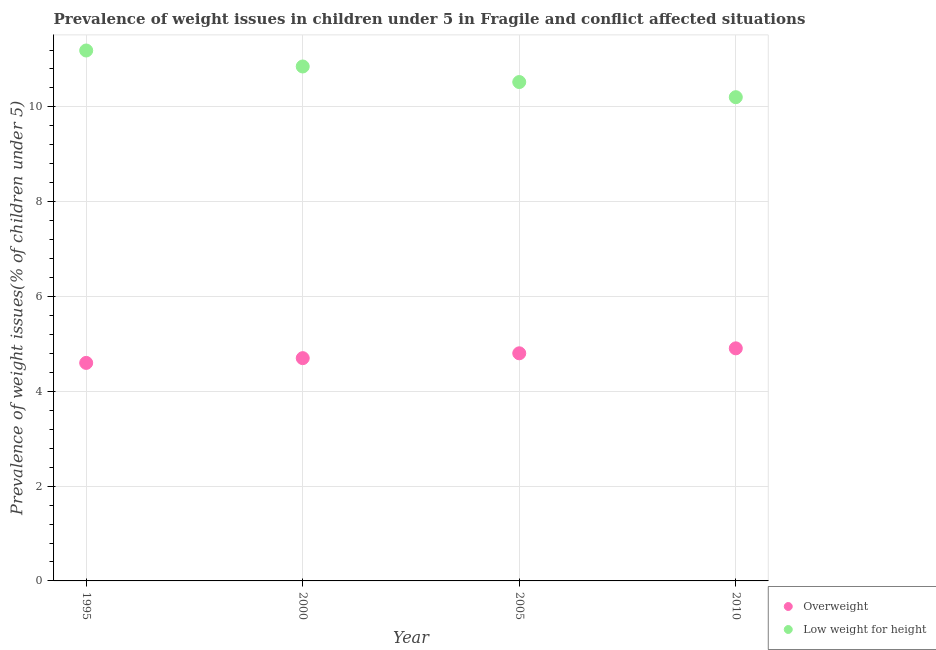How many different coloured dotlines are there?
Your response must be concise. 2. What is the percentage of underweight children in 2010?
Offer a very short reply. 10.2. Across all years, what is the maximum percentage of overweight children?
Ensure brevity in your answer.  4.91. Across all years, what is the minimum percentage of underweight children?
Provide a short and direct response. 10.2. In which year was the percentage of underweight children maximum?
Your response must be concise. 1995. In which year was the percentage of overweight children minimum?
Your response must be concise. 1995. What is the total percentage of underweight children in the graph?
Your answer should be compact. 42.77. What is the difference between the percentage of overweight children in 1995 and that in 2005?
Ensure brevity in your answer.  -0.2. What is the difference between the percentage of underweight children in 2010 and the percentage of overweight children in 1995?
Your response must be concise. 5.61. What is the average percentage of overweight children per year?
Give a very brief answer. 4.75. In the year 2005, what is the difference between the percentage of underweight children and percentage of overweight children?
Make the answer very short. 5.72. What is the ratio of the percentage of underweight children in 1995 to that in 2010?
Give a very brief answer. 1.1. What is the difference between the highest and the second highest percentage of underweight children?
Make the answer very short. 0.34. What is the difference between the highest and the lowest percentage of underweight children?
Provide a short and direct response. 0.99. In how many years, is the percentage of underweight children greater than the average percentage of underweight children taken over all years?
Ensure brevity in your answer.  2. Is the sum of the percentage of overweight children in 2000 and 2005 greater than the maximum percentage of underweight children across all years?
Make the answer very short. No. Is the percentage of overweight children strictly less than the percentage of underweight children over the years?
Make the answer very short. Yes. How many dotlines are there?
Your answer should be very brief. 2. How many years are there in the graph?
Your answer should be very brief. 4. Are the values on the major ticks of Y-axis written in scientific E-notation?
Offer a very short reply. No. Where does the legend appear in the graph?
Your response must be concise. Bottom right. How are the legend labels stacked?
Your response must be concise. Vertical. What is the title of the graph?
Give a very brief answer. Prevalence of weight issues in children under 5 in Fragile and conflict affected situations. Does "From production" appear as one of the legend labels in the graph?
Ensure brevity in your answer.  No. What is the label or title of the Y-axis?
Make the answer very short. Prevalence of weight issues(% of children under 5). What is the Prevalence of weight issues(% of children under 5) in Overweight in 1995?
Provide a short and direct response. 4.6. What is the Prevalence of weight issues(% of children under 5) in Low weight for height in 1995?
Give a very brief answer. 11.19. What is the Prevalence of weight issues(% of children under 5) of Overweight in 2000?
Keep it short and to the point. 4.7. What is the Prevalence of weight issues(% of children under 5) in Low weight for height in 2000?
Offer a terse response. 10.85. What is the Prevalence of weight issues(% of children under 5) of Overweight in 2005?
Ensure brevity in your answer.  4.8. What is the Prevalence of weight issues(% of children under 5) of Low weight for height in 2005?
Your answer should be compact. 10.52. What is the Prevalence of weight issues(% of children under 5) of Overweight in 2010?
Make the answer very short. 4.91. What is the Prevalence of weight issues(% of children under 5) in Low weight for height in 2010?
Provide a short and direct response. 10.2. Across all years, what is the maximum Prevalence of weight issues(% of children under 5) in Overweight?
Your answer should be very brief. 4.91. Across all years, what is the maximum Prevalence of weight issues(% of children under 5) of Low weight for height?
Keep it short and to the point. 11.19. Across all years, what is the minimum Prevalence of weight issues(% of children under 5) in Overweight?
Ensure brevity in your answer.  4.6. Across all years, what is the minimum Prevalence of weight issues(% of children under 5) of Low weight for height?
Provide a succinct answer. 10.2. What is the total Prevalence of weight issues(% of children under 5) in Overweight in the graph?
Keep it short and to the point. 19.01. What is the total Prevalence of weight issues(% of children under 5) of Low weight for height in the graph?
Your answer should be compact. 42.77. What is the difference between the Prevalence of weight issues(% of children under 5) in Overweight in 1995 and that in 2000?
Offer a terse response. -0.1. What is the difference between the Prevalence of weight issues(% of children under 5) in Low weight for height in 1995 and that in 2000?
Provide a short and direct response. 0.34. What is the difference between the Prevalence of weight issues(% of children under 5) in Overweight in 1995 and that in 2005?
Give a very brief answer. -0.2. What is the difference between the Prevalence of weight issues(% of children under 5) in Low weight for height in 1995 and that in 2005?
Your response must be concise. 0.67. What is the difference between the Prevalence of weight issues(% of children under 5) of Overweight in 1995 and that in 2010?
Keep it short and to the point. -0.31. What is the difference between the Prevalence of weight issues(% of children under 5) of Low weight for height in 1995 and that in 2010?
Offer a very short reply. 0.99. What is the difference between the Prevalence of weight issues(% of children under 5) of Overweight in 2000 and that in 2005?
Make the answer very short. -0.1. What is the difference between the Prevalence of weight issues(% of children under 5) of Low weight for height in 2000 and that in 2005?
Make the answer very short. 0.33. What is the difference between the Prevalence of weight issues(% of children under 5) in Overweight in 2000 and that in 2010?
Your answer should be very brief. -0.21. What is the difference between the Prevalence of weight issues(% of children under 5) in Low weight for height in 2000 and that in 2010?
Keep it short and to the point. 0.65. What is the difference between the Prevalence of weight issues(% of children under 5) of Overweight in 2005 and that in 2010?
Your response must be concise. -0.1. What is the difference between the Prevalence of weight issues(% of children under 5) of Low weight for height in 2005 and that in 2010?
Give a very brief answer. 0.32. What is the difference between the Prevalence of weight issues(% of children under 5) of Overweight in 1995 and the Prevalence of weight issues(% of children under 5) of Low weight for height in 2000?
Keep it short and to the point. -6.25. What is the difference between the Prevalence of weight issues(% of children under 5) in Overweight in 1995 and the Prevalence of weight issues(% of children under 5) in Low weight for height in 2005?
Your response must be concise. -5.93. What is the difference between the Prevalence of weight issues(% of children under 5) in Overweight in 1995 and the Prevalence of weight issues(% of children under 5) in Low weight for height in 2010?
Keep it short and to the point. -5.61. What is the difference between the Prevalence of weight issues(% of children under 5) of Overweight in 2000 and the Prevalence of weight issues(% of children under 5) of Low weight for height in 2005?
Provide a short and direct response. -5.82. What is the difference between the Prevalence of weight issues(% of children under 5) of Overweight in 2000 and the Prevalence of weight issues(% of children under 5) of Low weight for height in 2010?
Your answer should be very brief. -5.51. What is the difference between the Prevalence of weight issues(% of children under 5) in Overweight in 2005 and the Prevalence of weight issues(% of children under 5) in Low weight for height in 2010?
Give a very brief answer. -5.4. What is the average Prevalence of weight issues(% of children under 5) in Overweight per year?
Give a very brief answer. 4.75. What is the average Prevalence of weight issues(% of children under 5) in Low weight for height per year?
Provide a succinct answer. 10.69. In the year 1995, what is the difference between the Prevalence of weight issues(% of children under 5) in Overweight and Prevalence of weight issues(% of children under 5) in Low weight for height?
Provide a succinct answer. -6.59. In the year 2000, what is the difference between the Prevalence of weight issues(% of children under 5) of Overweight and Prevalence of weight issues(% of children under 5) of Low weight for height?
Provide a succinct answer. -6.15. In the year 2005, what is the difference between the Prevalence of weight issues(% of children under 5) of Overweight and Prevalence of weight issues(% of children under 5) of Low weight for height?
Your response must be concise. -5.72. In the year 2010, what is the difference between the Prevalence of weight issues(% of children under 5) of Overweight and Prevalence of weight issues(% of children under 5) of Low weight for height?
Give a very brief answer. -5.3. What is the ratio of the Prevalence of weight issues(% of children under 5) of Overweight in 1995 to that in 2000?
Ensure brevity in your answer.  0.98. What is the ratio of the Prevalence of weight issues(% of children under 5) of Low weight for height in 1995 to that in 2000?
Make the answer very short. 1.03. What is the ratio of the Prevalence of weight issues(% of children under 5) of Overweight in 1995 to that in 2005?
Make the answer very short. 0.96. What is the ratio of the Prevalence of weight issues(% of children under 5) in Low weight for height in 1995 to that in 2005?
Your answer should be very brief. 1.06. What is the ratio of the Prevalence of weight issues(% of children under 5) of Overweight in 1995 to that in 2010?
Make the answer very short. 0.94. What is the ratio of the Prevalence of weight issues(% of children under 5) of Low weight for height in 1995 to that in 2010?
Provide a short and direct response. 1.1. What is the ratio of the Prevalence of weight issues(% of children under 5) of Overweight in 2000 to that in 2005?
Give a very brief answer. 0.98. What is the ratio of the Prevalence of weight issues(% of children under 5) in Low weight for height in 2000 to that in 2005?
Keep it short and to the point. 1.03. What is the ratio of the Prevalence of weight issues(% of children under 5) of Overweight in 2000 to that in 2010?
Offer a terse response. 0.96. What is the ratio of the Prevalence of weight issues(% of children under 5) in Low weight for height in 2000 to that in 2010?
Your answer should be compact. 1.06. What is the ratio of the Prevalence of weight issues(% of children under 5) in Overweight in 2005 to that in 2010?
Provide a short and direct response. 0.98. What is the ratio of the Prevalence of weight issues(% of children under 5) of Low weight for height in 2005 to that in 2010?
Your response must be concise. 1.03. What is the difference between the highest and the second highest Prevalence of weight issues(% of children under 5) of Overweight?
Provide a succinct answer. 0.1. What is the difference between the highest and the second highest Prevalence of weight issues(% of children under 5) in Low weight for height?
Provide a succinct answer. 0.34. What is the difference between the highest and the lowest Prevalence of weight issues(% of children under 5) of Overweight?
Keep it short and to the point. 0.31. What is the difference between the highest and the lowest Prevalence of weight issues(% of children under 5) of Low weight for height?
Your answer should be very brief. 0.99. 